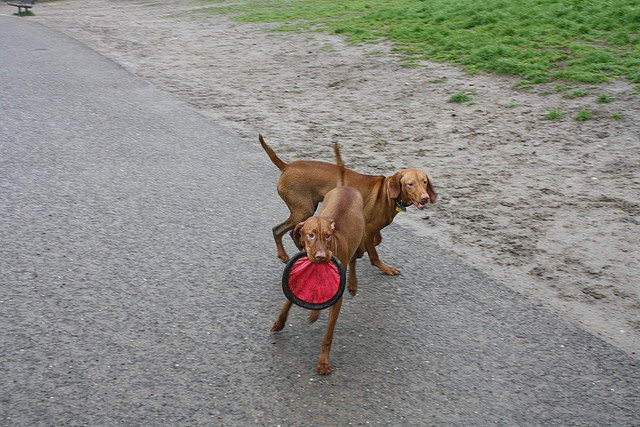Describe the objects in this image and their specific colors. I can see dog in gray, maroon, brown, and black tones, dog in gray, maroon, and black tones, frisbee in gray, brown, black, and maroon tones, and bench in gray, darkgreen, darkgray, and black tones in this image. 